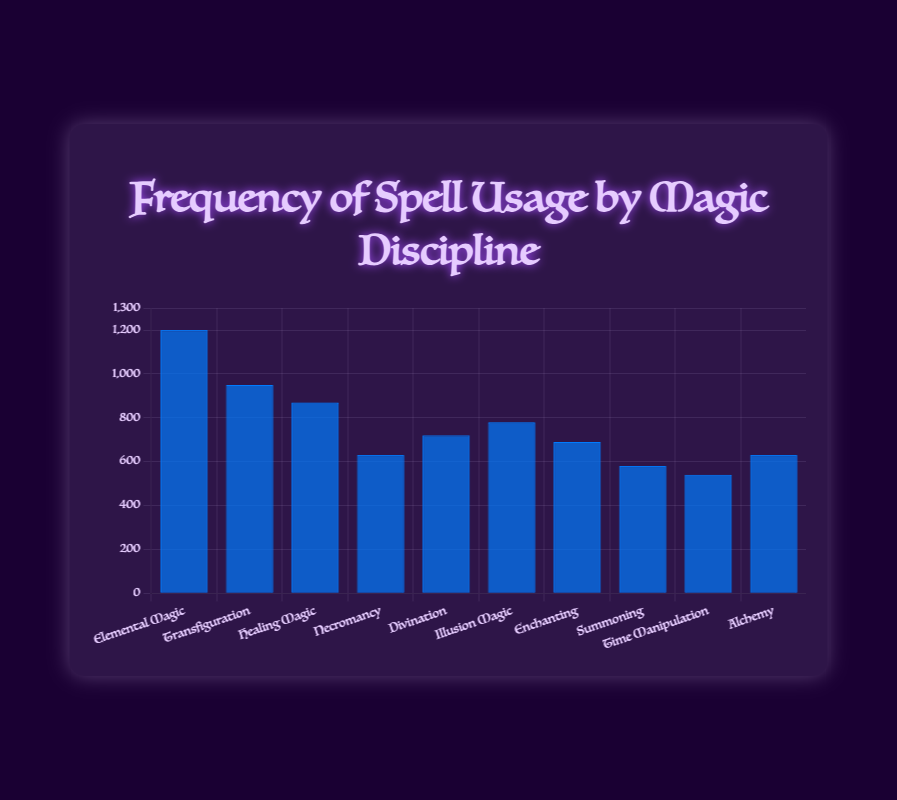Which magic discipline has the highest spell usage frequency? The bar representing Elemental Magic is the tallest, with a frequency of 1200, thus it has the highest spell usage frequency.
Answer: Elemental Magic Which magic discipline has the lowest spell usage frequency? The bar representing Time Manipulation is the shortest, with a frequency of 540, thus it has the lowest spell usage frequency.
Answer: Time Manipulation What is the difference in spell usage frequency between Elemental Magic and Healing Magic? The spell usage frequency for Elemental Magic is 1200, and for Healing Magic is 870. The difference is 1200 - 870 = 330.
Answer: 330 Which magic disciplines have a spell usage frequency of more than 700? The bars for Elemental Magic (1200), Transfiguration (950), Healing Magic (870), Illusion Magic (780), and Divination (720) are all taller than the 700 frequency mark.
Answer: Elemental Magic, Transfiguration, Healing Magic, Illusion Magic, Divination What is the average spell usage frequency of all magic disciplines? Sum all frequencies: 1200 + 950 + 870 + 630 + 720 + 780 + 690 + 580 + 540 + 630 = 7590. There are 10 disciplines, so the average is 7590 / 10 = 759.
Answer: 759 Is the spell usage frequency of Transfiguration more than double that of Summoning? The spell usage frequency of Transfiguration is 950 and that of Summoning is 580. Double of Summoning's frequency is 580 * 2 = 1160. Since 950 is less than 1160, the frequency of Transfiguration is not more than double that of Summoning.
Answer: No Which two magic disciplines combined have the closest spell usage frequency to 1000? Healing Magic has a frequency of 870, and Enchanting has 690. Combining them: 870 + 690 = 1560. Now try Necromancy (630) and Alchemy (630): 630 + 630 = 1260. Finally, try Summoning (580) and Time Manipulation (540): 580 + 540 = 1120. The closest to 1000 is 1120 from Summoning and Time Manipulation.
Answer: Summoning and Time Manipulation What is the median spell usage frequency of the magic disciplines? Arrange frequencies in ascending order: 540, 580, 630, 630, 690, 720, 780, 870, 950, 1200. The median is the average of the 5th and 6th values, (690 + 720) / 2 = 705.
Answer: 705 Between Illusion Magic and Enchanting, which one has a higher spell usage frequency? The spell usage frequency for Illusion Magic is 780, while for Enchanting it is 690. Illusion Magic has a higher frequency.
Answer: Illusion Magic How much difference in spell usage frequency is there between Divination and Necromancy? The spell usage frequency of Divination is 720 and Necromancy is 630. The difference is 720 - 630 = 90.
Answer: 90 